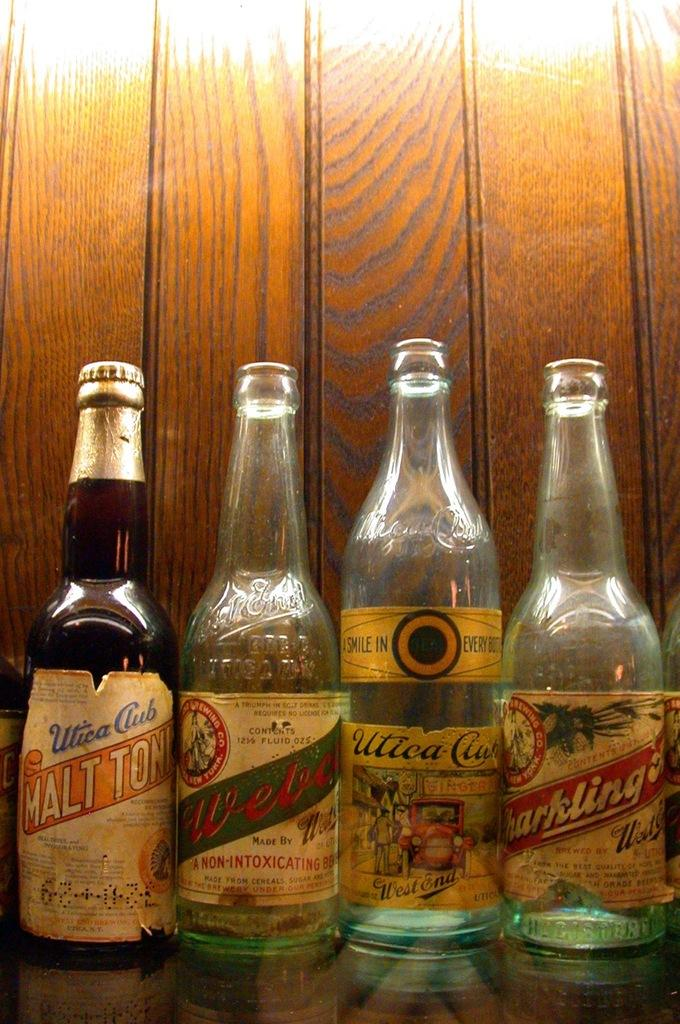<image>
Describe the image concisely. Several glass drink bottles including both alcoholic and non-alcoholic beverages. 